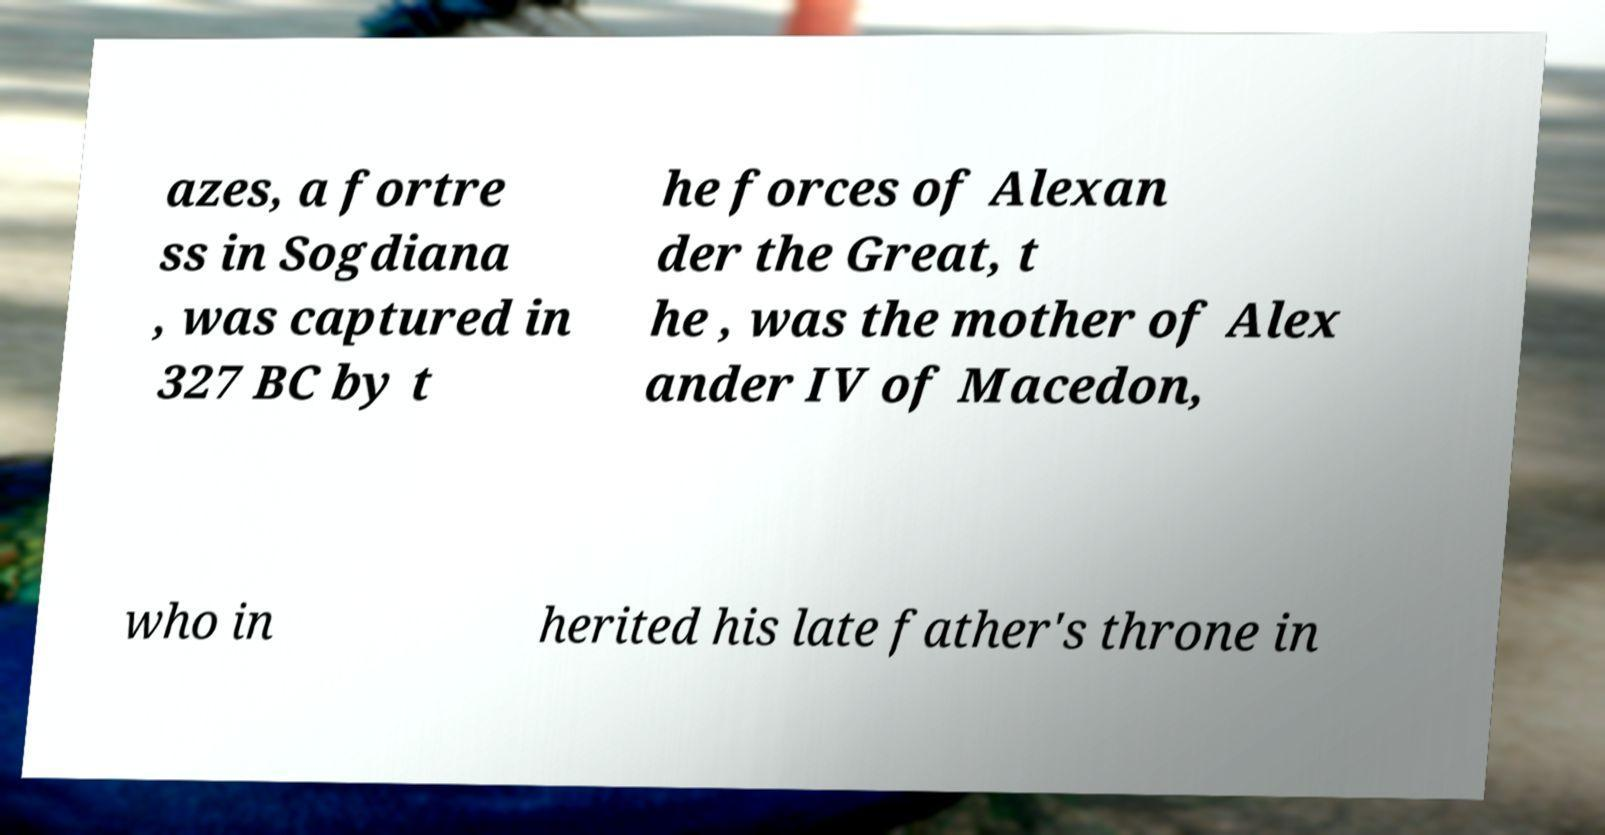What messages or text are displayed in this image? I need them in a readable, typed format. azes, a fortre ss in Sogdiana , was captured in 327 BC by t he forces of Alexan der the Great, t he , was the mother of Alex ander IV of Macedon, who in herited his late father's throne in 